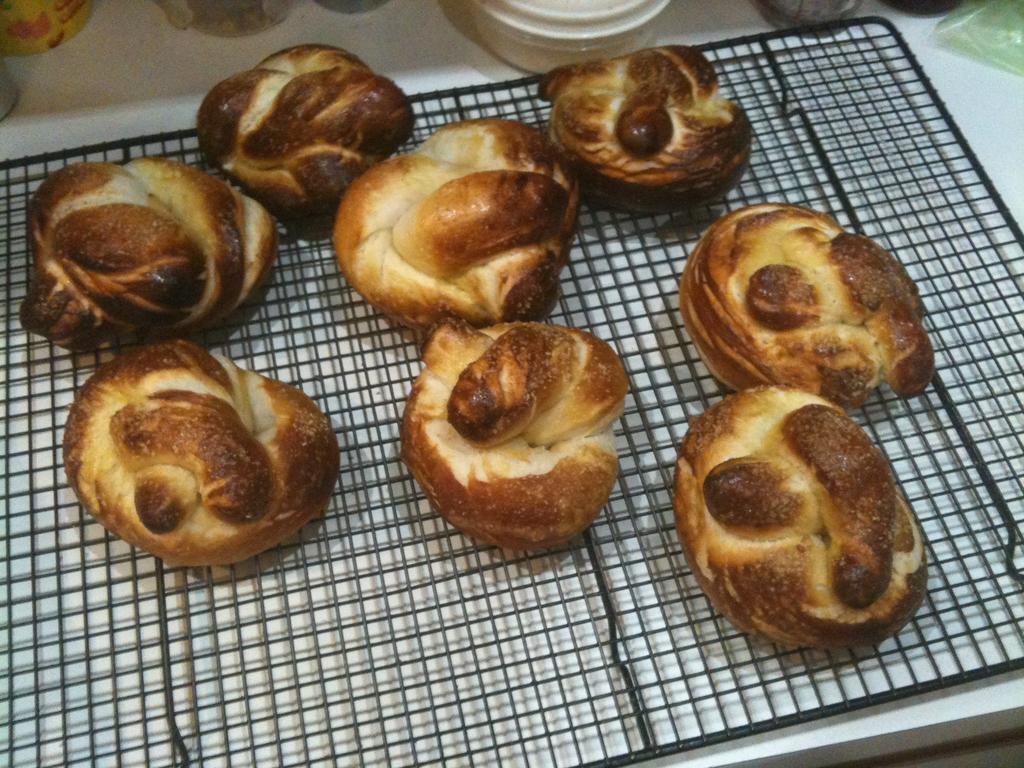In one or two sentences, can you explain what this image depicts? In this picture, we can see some food items on the metallic object, we can see some objects on top side of the picture. 